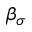Convert formula to latex. <formula><loc_0><loc_0><loc_500><loc_500>\beta _ { \sigma }</formula> 